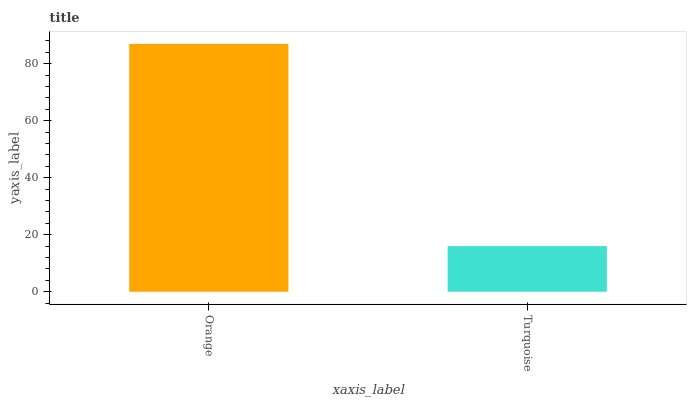Is Turquoise the maximum?
Answer yes or no. No. Is Orange greater than Turquoise?
Answer yes or no. Yes. Is Turquoise less than Orange?
Answer yes or no. Yes. Is Turquoise greater than Orange?
Answer yes or no. No. Is Orange less than Turquoise?
Answer yes or no. No. Is Orange the high median?
Answer yes or no. Yes. Is Turquoise the low median?
Answer yes or no. Yes. Is Turquoise the high median?
Answer yes or no. No. Is Orange the low median?
Answer yes or no. No. 